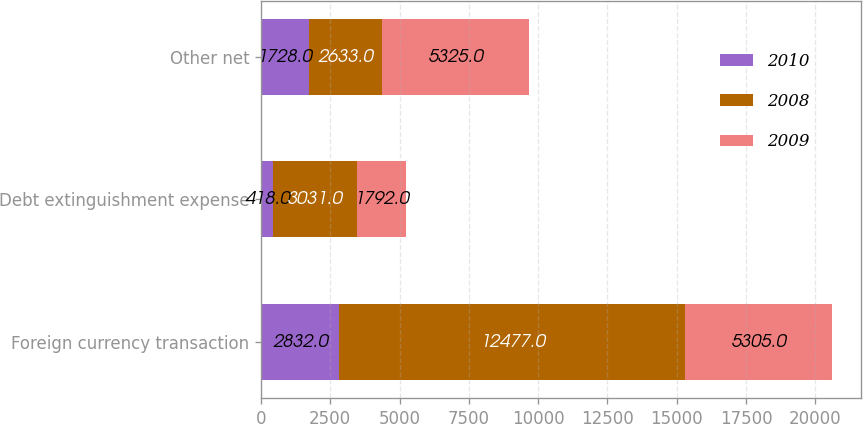Convert chart to OTSL. <chart><loc_0><loc_0><loc_500><loc_500><stacked_bar_chart><ecel><fcel>Foreign currency transaction<fcel>Debt extinguishment expense<fcel>Other net<nl><fcel>2010<fcel>2832<fcel>418<fcel>1728<nl><fcel>2008<fcel>12477<fcel>3031<fcel>2633<nl><fcel>2009<fcel>5305<fcel>1792<fcel>5325<nl></chart> 